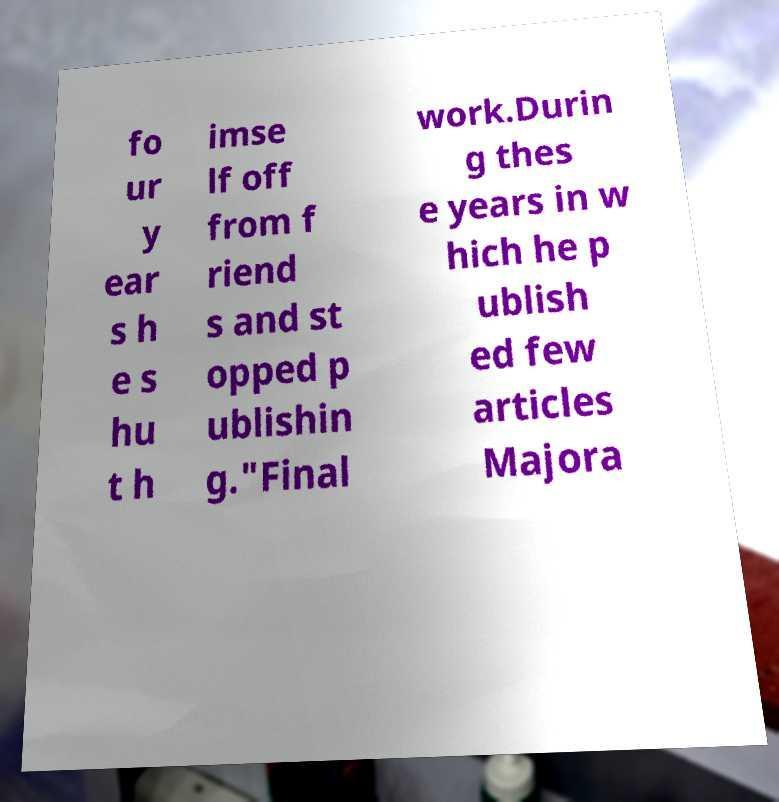I need the written content from this picture converted into text. Can you do that? fo ur y ear s h e s hu t h imse lf off from f riend s and st opped p ublishin g."Final work.Durin g thes e years in w hich he p ublish ed few articles Majora 